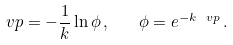<formula> <loc_0><loc_0><loc_500><loc_500>\ v p = - \frac { 1 } { k } \ln \phi \, , \quad \phi = e ^ { - k \ v p } \, .</formula> 